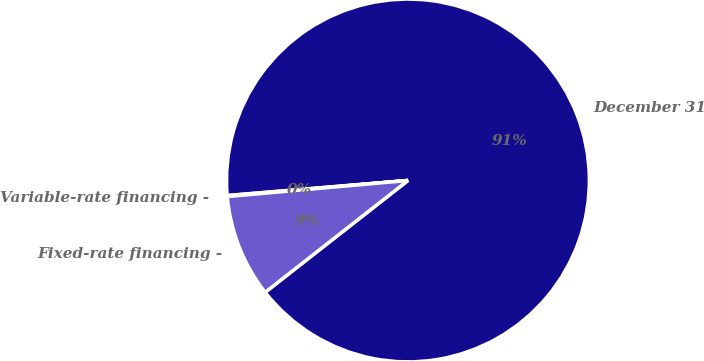Convert chart. <chart><loc_0><loc_0><loc_500><loc_500><pie_chart><fcel>December 31<fcel>Variable-rate financing -<fcel>Fixed-rate financing -<nl><fcel>90.75%<fcel>0.09%<fcel>9.16%<nl></chart> 